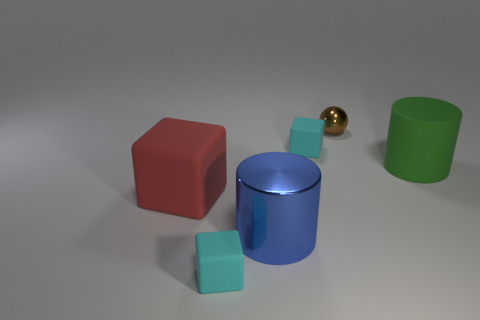Does the rubber cylinder have the same size as the cylinder in front of the big green matte object?
Make the answer very short. Yes. The tiny shiny thing has what color?
Your answer should be compact. Brown. There is a metal object that is the same size as the green cylinder; what is its shape?
Your response must be concise. Cylinder. Does the large rubber cylinder have the same color as the tiny thing in front of the green cylinder?
Give a very brief answer. No. Are there any shiny things that are to the right of the big cylinder in front of the red rubber block that is in front of the brown sphere?
Make the answer very short. Yes. There is a big object that is made of the same material as the sphere; what is its color?
Offer a very short reply. Blue. How many small gray objects are made of the same material as the blue object?
Your answer should be very brief. 0. Does the brown sphere have the same material as the large thing in front of the big block?
Your answer should be very brief. Yes. What number of things are matte objects that are behind the big blue cylinder or big cyan metallic cylinders?
Provide a short and direct response. 3. There is a cube to the right of the tiny cyan matte cube on the left side of the rubber cube behind the green rubber cylinder; what size is it?
Offer a very short reply. Small. 